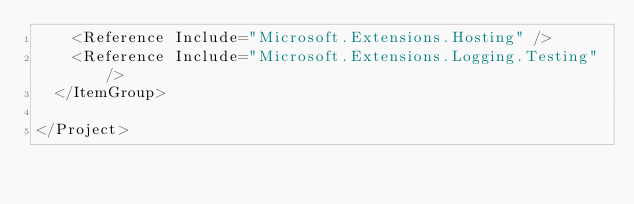Convert code to text. <code><loc_0><loc_0><loc_500><loc_500><_XML_>    <Reference Include="Microsoft.Extensions.Hosting" />
    <Reference Include="Microsoft.Extensions.Logging.Testing" />
  </ItemGroup>

</Project>
</code> 